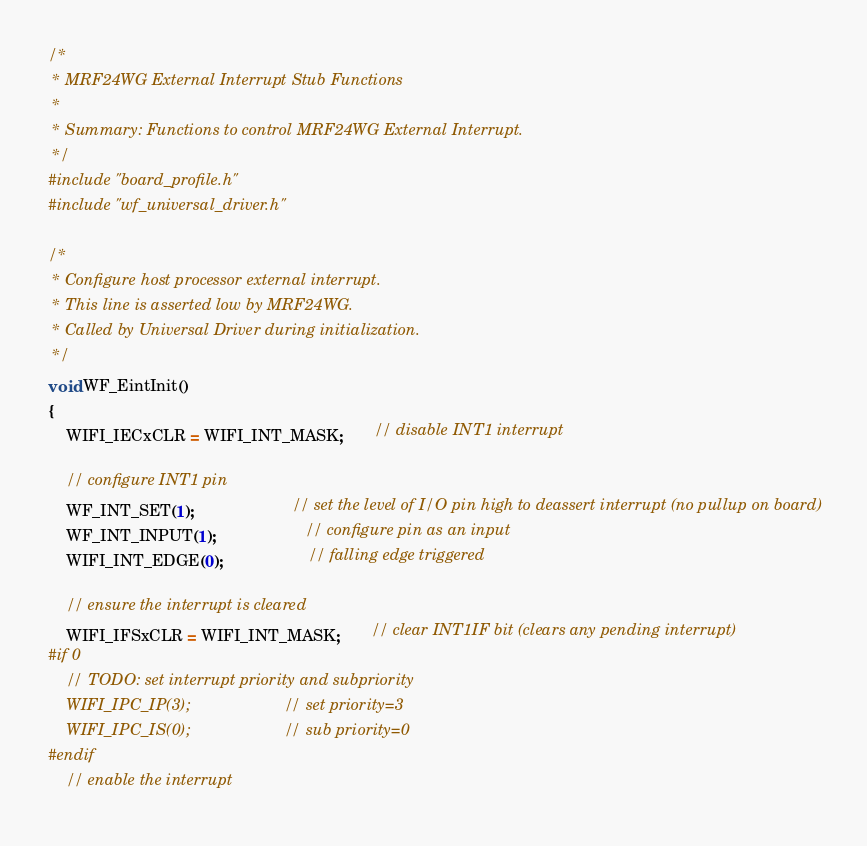Convert code to text. <code><loc_0><loc_0><loc_500><loc_500><_C_>/*
 * MRF24WG External Interrupt Stub Functions
 *
 * Summary: Functions to control MRF24WG External Interrupt.
 */
#include "board_profile.h"
#include "wf_universal_driver.h"

/*
 * Configure host processor external interrupt.
 * This line is asserted low by MRF24WG.
 * Called by Universal Driver during initialization.
 */
void WF_EintInit()
{
    WIFI_IECxCLR = WIFI_INT_MASK;       // disable INT1 interrupt

    // configure INT1 pin
    WF_INT_SET(1);                      // set the level of I/O pin high to deassert interrupt (no pullup on board)
    WF_INT_INPUT(1);                    // configure pin as an input
    WIFI_INT_EDGE(0);                   // falling edge triggered

    // ensure the interrupt is cleared
    WIFI_IFSxCLR = WIFI_INT_MASK;       // clear INT1IF bit (clears any pending interrupt)
#if 0
    // TODO: set interrupt priority and subpriority
    WIFI_IPC_IP(3);                     // set priority=3
    WIFI_IPC_IS(0);                     // sub priority=0
#endif
    // enable the interrupt</code> 